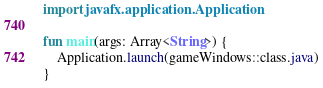Convert code to text. <code><loc_0><loc_0><loc_500><loc_500><_Kotlin_>import javafx.application.Application

fun main(args: Array<String>) {
    Application.launch(gameWindows::class.java)
}</code> 